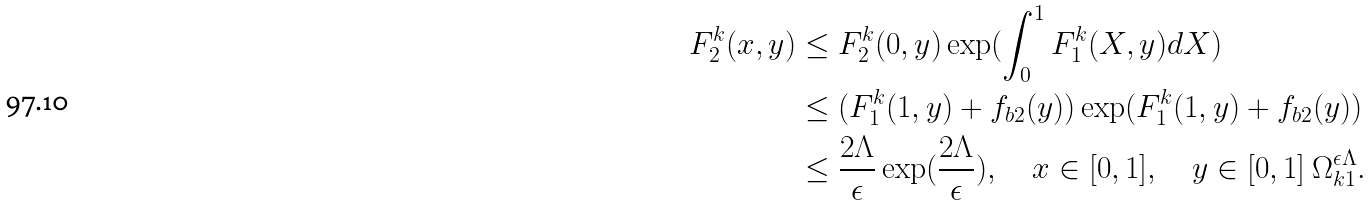<formula> <loc_0><loc_0><loc_500><loc_500>F ^ { k } _ { 2 } ( x , y ) & \leq F ^ { k } _ { 2 } ( 0 , y ) \exp ( \int _ { 0 } ^ { 1 } F ^ { k } _ { 1 } ( X , y ) d X ) \\ & \leq ( F ^ { k } _ { 1 } ( 1 , y ) + f _ { b 2 } ( y ) ) \exp ( F ^ { k } _ { 1 } ( 1 , y ) + f _ { b 2 } ( y ) ) \\ & \leq \frac { 2 \Lambda } { \epsilon } \exp ( \frac { 2 \Lambda } { \epsilon } ) , \quad x \in [ 0 , 1 ] , \quad y \in [ 0 , 1 ] \ \Omega ^ { \epsilon \Lambda } _ { k 1 } .</formula> 